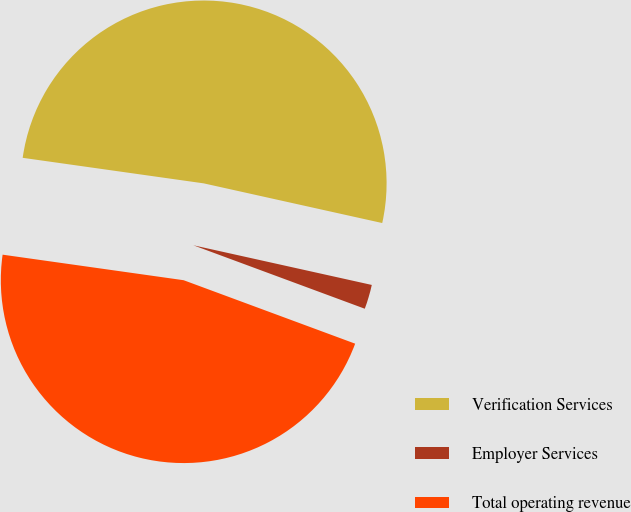Convert chart. <chart><loc_0><loc_0><loc_500><loc_500><pie_chart><fcel>Verification Services<fcel>Employer Services<fcel>Total operating revenue<nl><fcel>51.25%<fcel>2.16%<fcel>46.59%<nl></chart> 